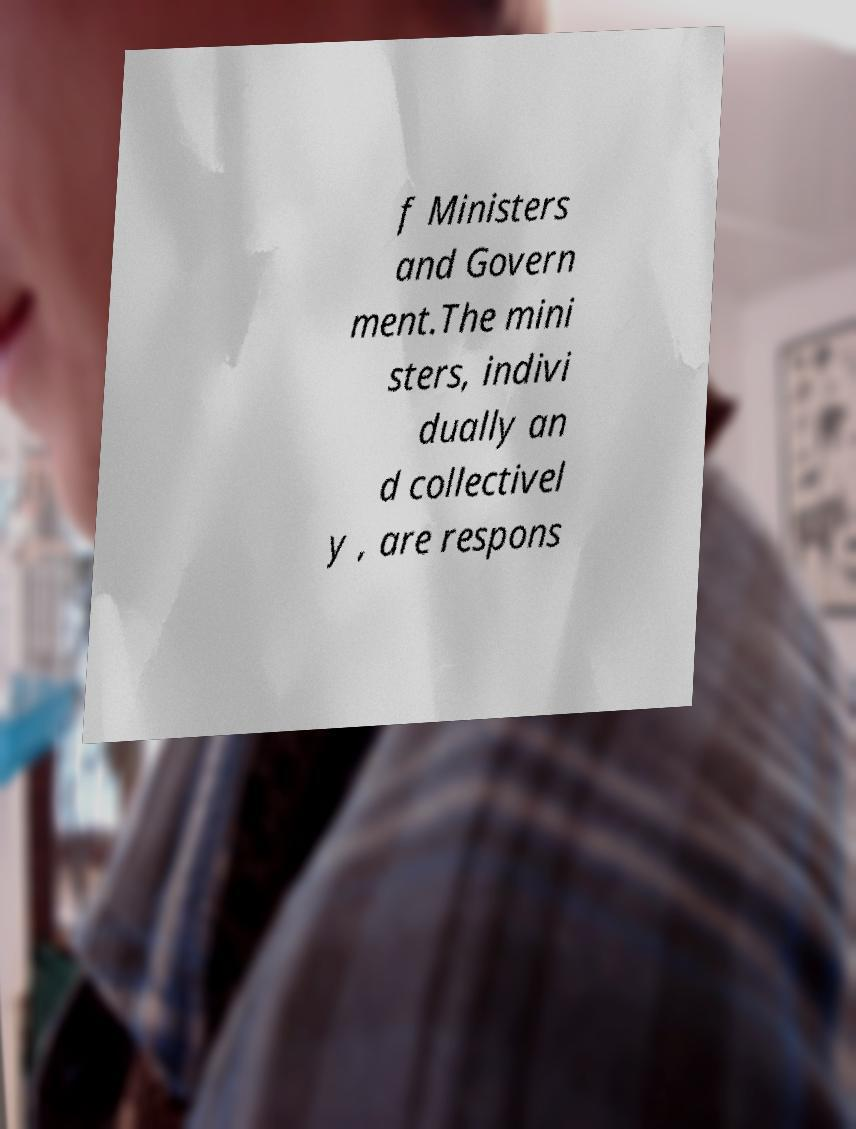For documentation purposes, I need the text within this image transcribed. Could you provide that? f Ministers and Govern ment.The mini sters, indivi dually an d collectivel y , are respons 